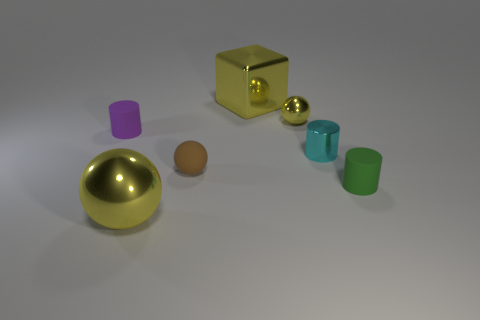There is a tiny purple object that is the same shape as the tiny cyan thing; what is it made of?
Your response must be concise. Rubber. The cyan metallic object is what shape?
Your answer should be very brief. Cylinder. There is a object that is both behind the small cyan metal object and on the left side of the brown rubber sphere; what is its material?
Keep it short and to the point. Rubber. What shape is the small green thing that is the same material as the purple object?
Provide a short and direct response. Cylinder. There is a brown sphere that is the same material as the purple cylinder; what size is it?
Your answer should be very brief. Small. The tiny thing that is behind the small metal cylinder and to the right of the matte sphere has what shape?
Your response must be concise. Sphere. What size is the matte thing that is left of the big thing that is to the left of the small brown rubber object?
Keep it short and to the point. Small. How many other objects are there of the same color as the small shiny sphere?
Your response must be concise. 2. What material is the tiny purple object?
Make the answer very short. Rubber. Are there any large objects?
Offer a terse response. Yes. 